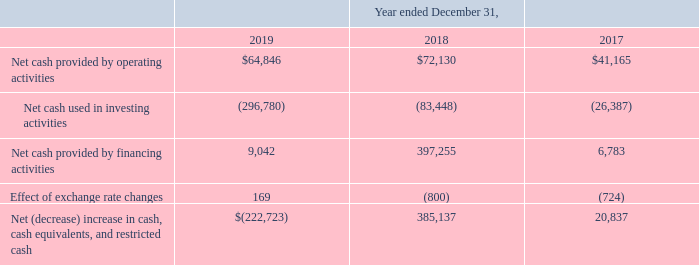Liquidity and Capital Resources
As of December 31, 2019 and 2018, we had cash and cash equivalents of $343.6 million and $566.3 million, respectively. We finance our operations primarily through sales to our customers and a majority of our customers are billed monthly. For customers with annual or multi-year contracts and those who opt for annual invoicing, we generally invoice only one annual period in advance and all invoicing occurs at the start of the respective subscription period. Revenue is deferred for such advanced billings. We also finance our operations from proceeds from issuance of stock under our stock plans, and proceeds from issuance of debt. We believe that our operations and existing liquidity sources will satisfy our cash requirements for at least the next 12 months
Our future capital requirements will depend on many factors, including revenue growth and costs incurred to support customer growth, acquisitions and expansions, sales and marketing, research and development, increased general and administrative expenses to support the anticipated growth in our operations, and capital equipment required to support our growing headcount and in support of our co-location data center facilities. Our capital expenditures in future periods are expected to grow in line with our business. We continually evaluate our capital needs and may decide to raise additional capital to fund the growth of our business, to further strengthen our balance sheet, or for general corporate purposes through public or private equity offerings or through additional debt financing. We also may in the future make investments in or acquire businesses or technologies that could require us to seek additional equity or debt financing. Access to additional capital may not be available, or on favorable terms
The table below provides selected cash flow information for the periods indicated (in thousands)
What are the respective values of the cash and cash equivalents as of December 31, 2019 and 2018?  $343.6 million, $566.3 million. What are the respective net cash provided by operating activities between 2017 to 2019?
Answer scale should be: thousand. $41,165, $72,130, $64,846. What are the respective net cash used by financing activities between 2017 to 2019?
Answer scale should be: thousand. 6,783, 397,255, 9,042. What is the percentage change in the net cash provided by operating activities between 2017 and 2018?
Answer scale should be: percent. (72,130 - 41,165)/41,165 
Answer: 75.22. What is the percentage change in the net cash provided by operating activities between 2018 and 2019?
Answer scale should be: percent. (64,846 - 72,130)/72,130 
Answer: -10.1. What is the total net cash provided by financing activities between 2017 to 2019?
Answer scale should be: thousand. 6,783 + 397,255 + 9,042 
Answer: 413080. 